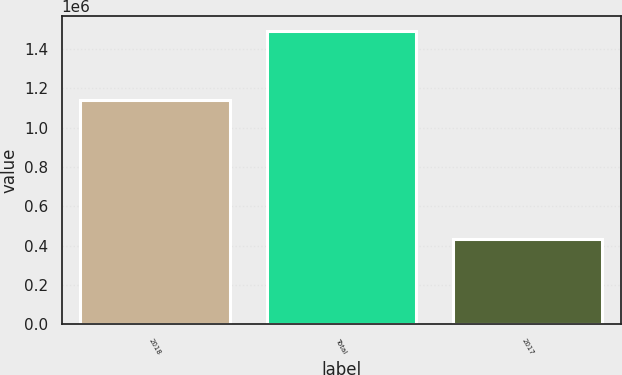Convert chart. <chart><loc_0><loc_0><loc_500><loc_500><bar_chart><fcel>2018<fcel>Total<fcel>2017<nl><fcel>1.13975e+06<fcel>1.49387e+06<fcel>432328<nl></chart> 